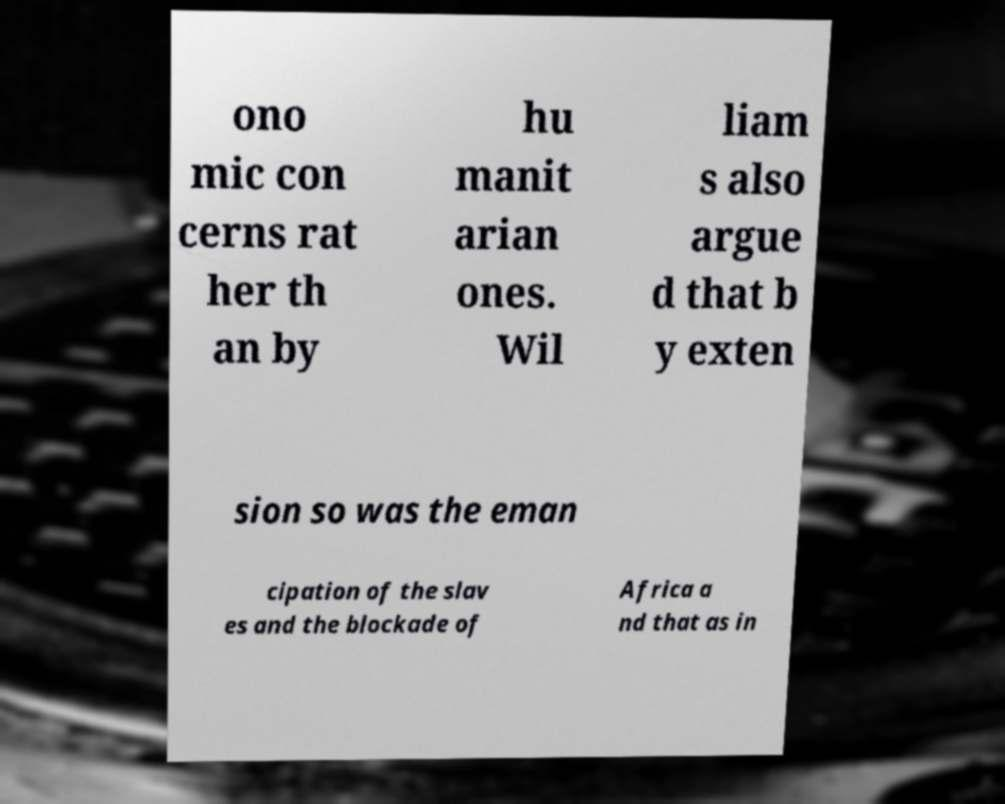Could you assist in decoding the text presented in this image and type it out clearly? ono mic con cerns rat her th an by hu manit arian ones. Wil liam s also argue d that b y exten sion so was the eman cipation of the slav es and the blockade of Africa a nd that as in 